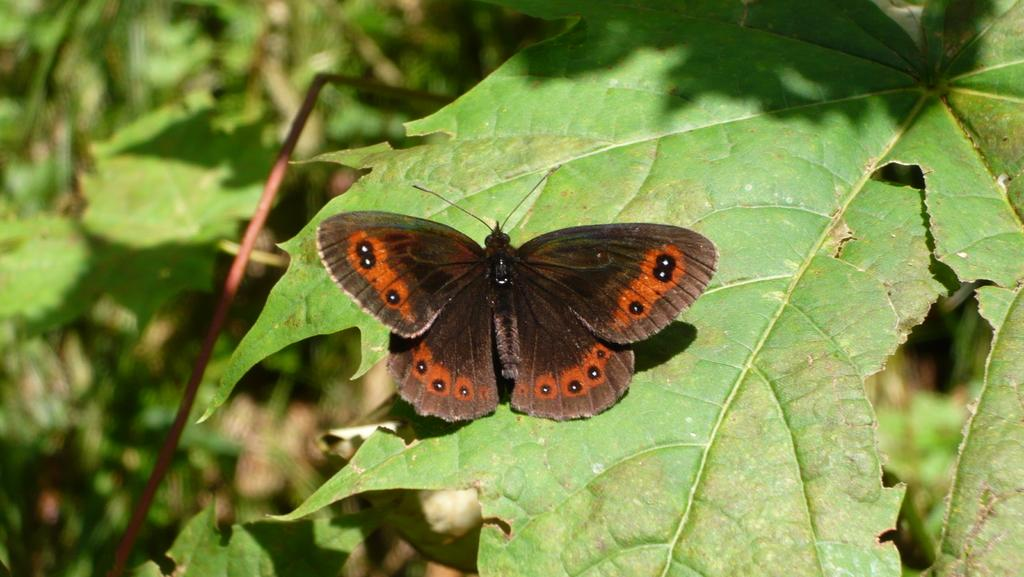What color is the leaf in the image? The leaf in the image is green. What is sitting on the leaf? There is a black color butterfly sitting on the leaf. Can you describe the background of the image? The background of the image is blurred. What type of gold border can be seen around the leaf in the image? There is no gold border present around the leaf in the image. What store can be seen in the background of the image? There is no store visible in the image; the background is blurred. 